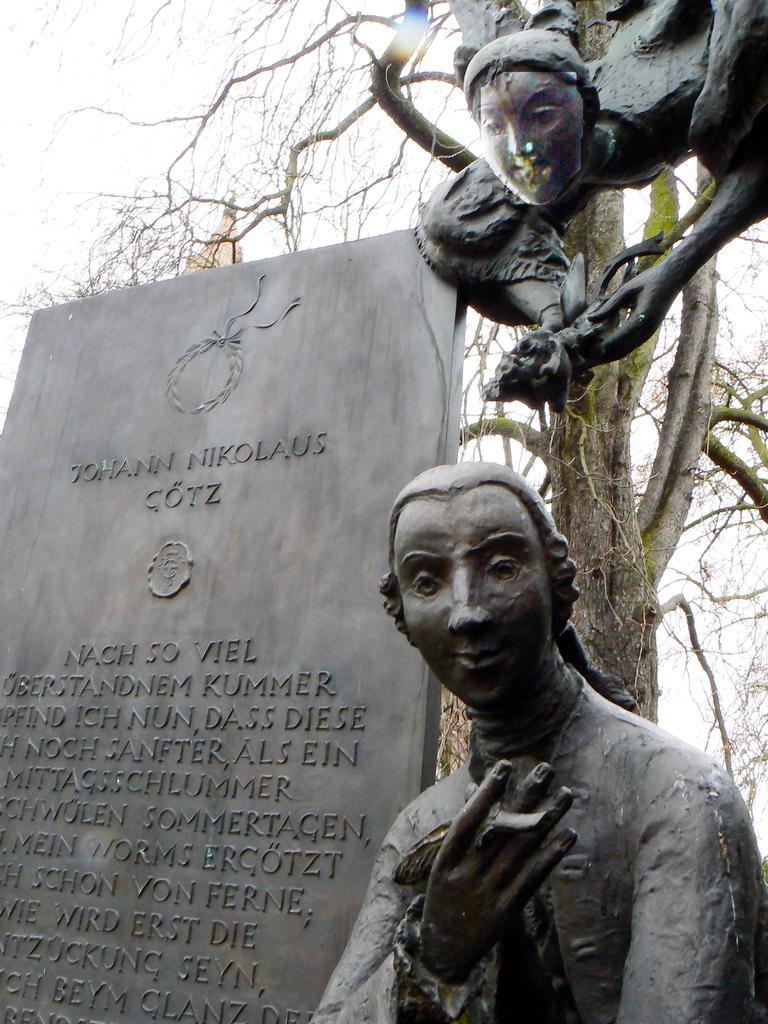Please provide a concise description of this image. Something written on this stone. Here we can see sculptures. Backside there is a tree. 